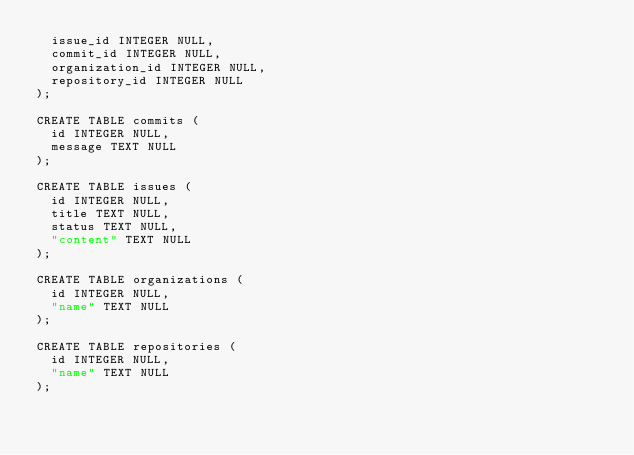<code> <loc_0><loc_0><loc_500><loc_500><_SQL_>	issue_id INTEGER NULL,
	commit_id INTEGER NULL,
	organization_id INTEGER NULL,
	repository_id INTEGER NULL
);

CREATE TABLE commits (
	id INTEGER NULL,
	message TEXT NULL
);

CREATE TABLE issues (
	id INTEGER NULL,
	title TEXT NULL,
	status TEXT NULL,
	"content" TEXT NULL
);

CREATE TABLE organizations (
	id INTEGER NULL,
	"name" TEXT NULL
);

CREATE TABLE repositories (
	id INTEGER NULL,
	"name" TEXT NULL
);
</code> 